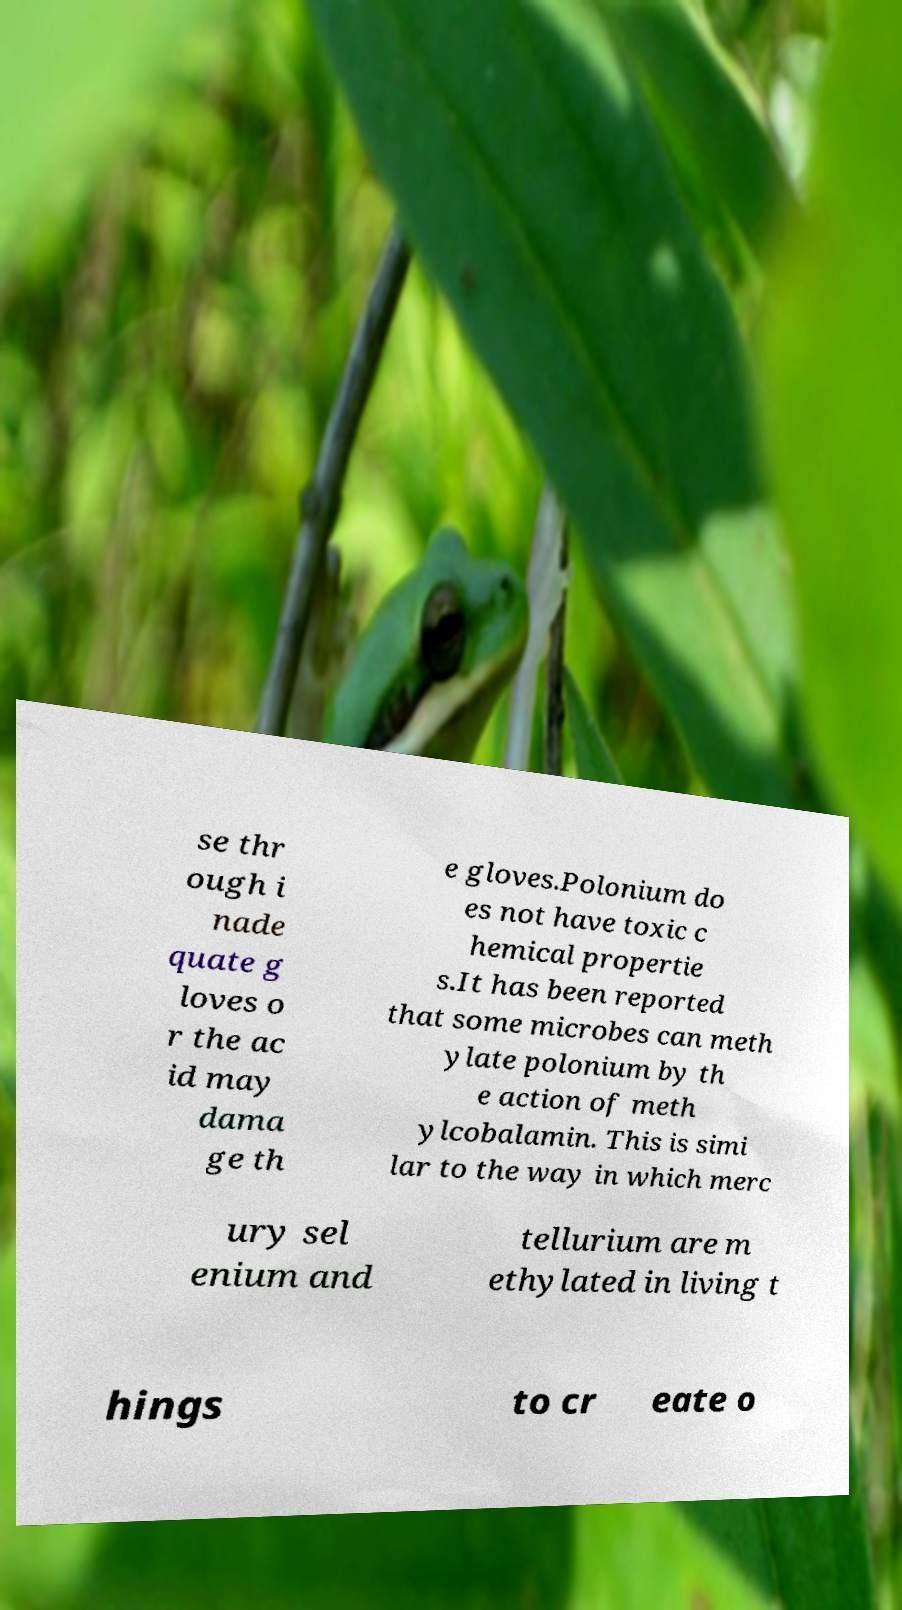Please identify and transcribe the text found in this image. se thr ough i nade quate g loves o r the ac id may dama ge th e gloves.Polonium do es not have toxic c hemical propertie s.It has been reported that some microbes can meth ylate polonium by th e action of meth ylcobalamin. This is simi lar to the way in which merc ury sel enium and tellurium are m ethylated in living t hings to cr eate o 